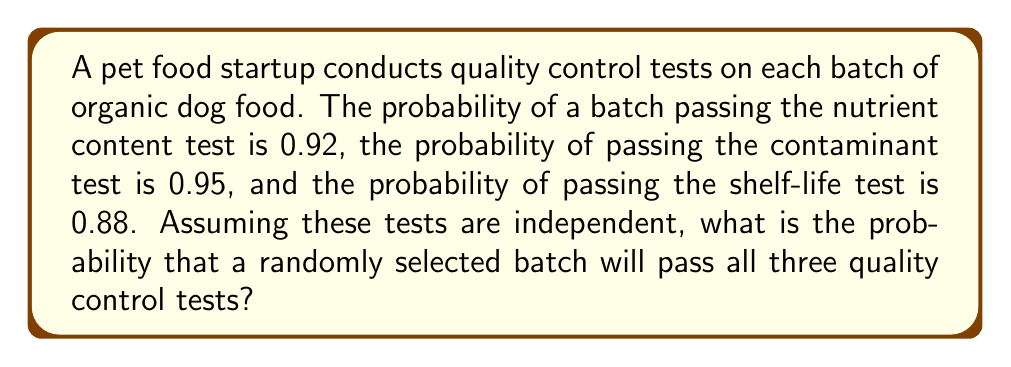Help me with this question. To solve this problem, we need to use the concept of independent events and the multiplication rule of probability.

Given:
- P(passing nutrient content test) = 0.92
- P(passing contaminant test) = 0.95
- P(passing shelf-life test) = 0.88

Since the tests are independent, the probability of all three events occurring together is the product of their individual probabilities.

Let A = passing nutrient content test
Let B = passing contaminant test
Let C = passing shelf-life test

We want to find P(A ∩ B ∩ C)

For independent events: P(A ∩ B ∩ C) = P(A) × P(B) × P(C)

Substituting the given probabilities:

$$P(A \cap B \cap C) = 0.92 \times 0.95 \times 0.88$$

Calculating:
$$P(A \cap B \cap C) = 0.7696 \times 0.88 = 0.677408$$

Therefore, the probability that a randomly selected batch will pass all three quality control tests is approximately 0.6774 or 67.74%.
Answer: 0.6774 or 67.74% 